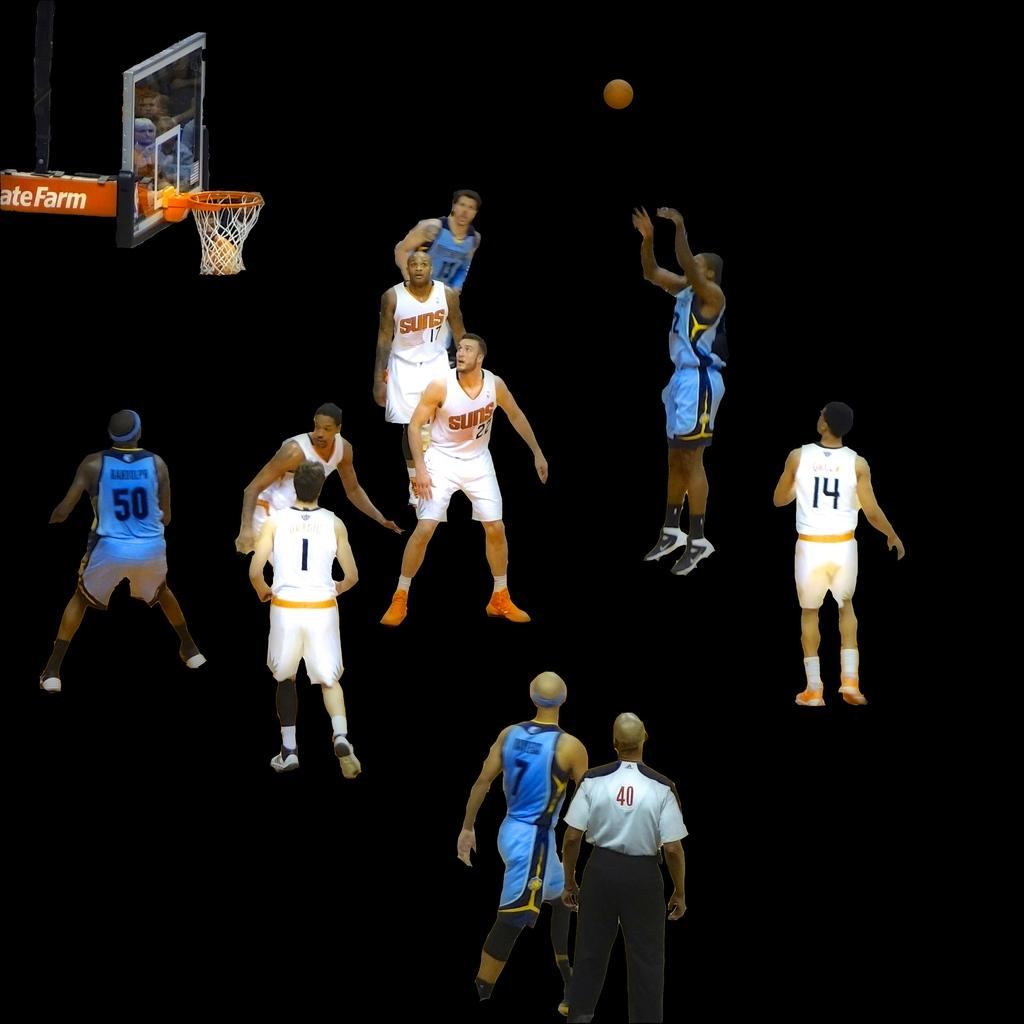Provide a one-sentence caption for the provided image. A basketball gave is underway and one teams' jerseys say Suns and the court is a dark background. 